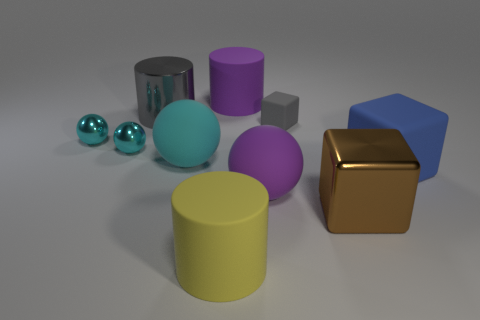Subtract all red cubes. How many cyan balls are left? 3 Subtract all purple spheres. How many spheres are left? 3 Subtract all large rubber cylinders. How many cylinders are left? 1 Subtract all green spheres. Subtract all cyan cylinders. How many spheres are left? 4 Subtract all cylinders. How many objects are left? 7 Add 6 big blue blocks. How many big blue blocks exist? 7 Subtract 0 cyan cubes. How many objects are left? 10 Subtract all large rubber cubes. Subtract all cyan shiny objects. How many objects are left? 7 Add 5 small metallic spheres. How many small metallic spheres are left? 7 